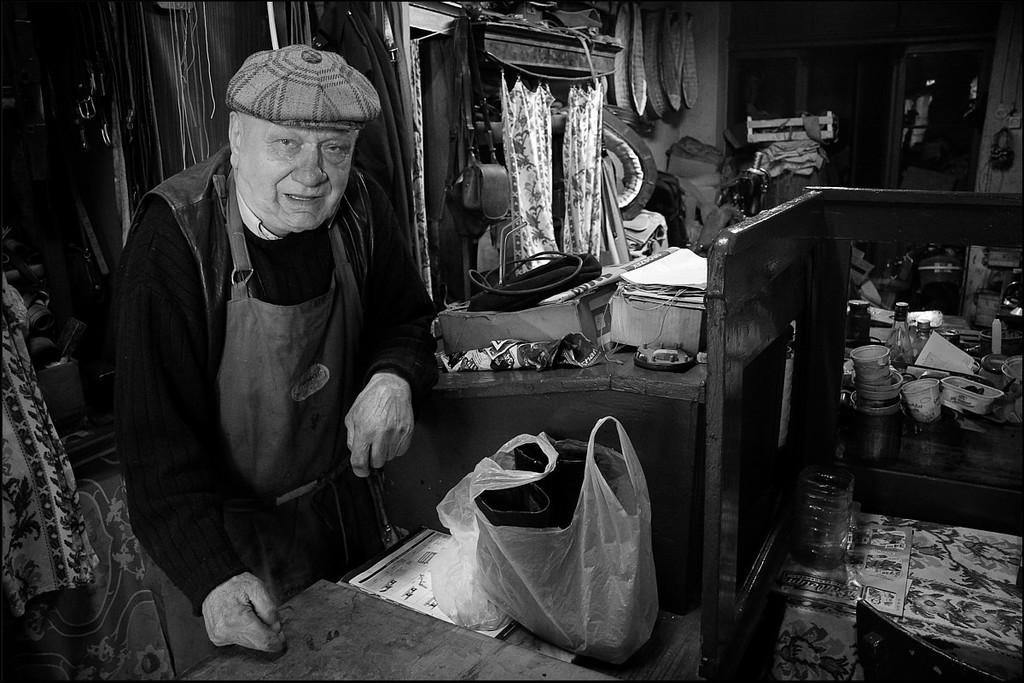Who is present in the image? There is a man in the image. What is on the table in the image? There is a plastic cover or paper on the table. What type of containers can be seen in the image? There are cups and bottles visible in the image. What can be seen in the background of the image? There are curtains and boxes in the background of the image. What type of steel structure is being protested in the image? There is no steel structure or protest present in the image. 